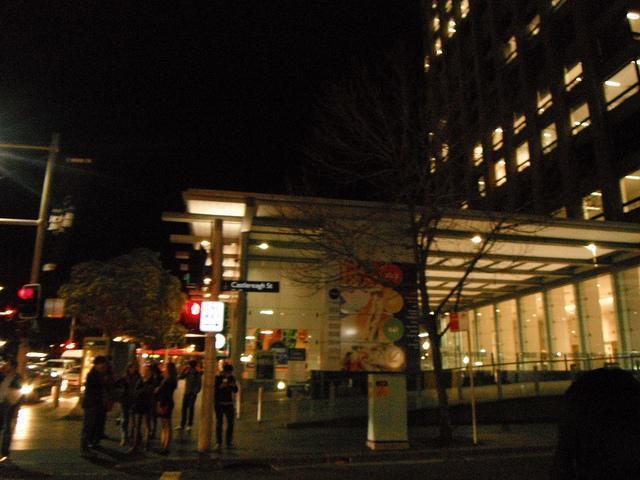What are the people waiting to do?
Indicate the correct response and explain using: 'Answer: answer
Rationale: rationale.'
Options: Eat, work, speak, cross. Answer: cross.
Rationale: They are pedestrians and are standing at the side of the road where there is a crosswalk. 